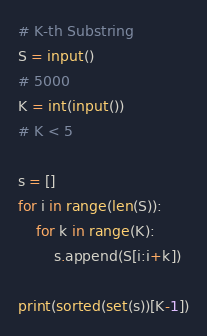<code> <loc_0><loc_0><loc_500><loc_500><_Python_># K-th Substring
S = input()
# 5000
K = int(input())
# K < 5

s = []
for i in range(len(S)):
    for k in range(K):
        s.append(S[i:i+k])

print(sorted(set(s))[K-1])</code> 